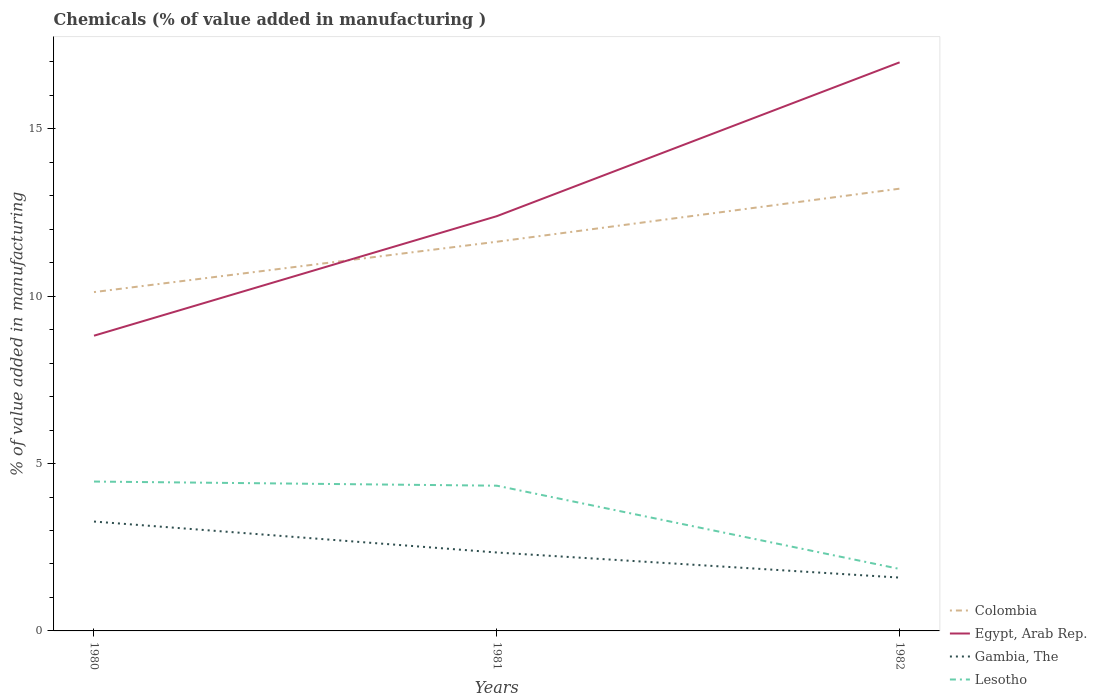How many different coloured lines are there?
Make the answer very short. 4. Does the line corresponding to Lesotho intersect with the line corresponding to Gambia, The?
Keep it short and to the point. No. Is the number of lines equal to the number of legend labels?
Ensure brevity in your answer.  Yes. Across all years, what is the maximum value added in manufacturing chemicals in Lesotho?
Keep it short and to the point. 1.85. What is the total value added in manufacturing chemicals in Lesotho in the graph?
Ensure brevity in your answer.  2.61. What is the difference between the highest and the second highest value added in manufacturing chemicals in Colombia?
Your response must be concise. 3.09. What is the difference between the highest and the lowest value added in manufacturing chemicals in Gambia, The?
Keep it short and to the point. 1. Does the graph contain grids?
Ensure brevity in your answer.  No. How are the legend labels stacked?
Provide a succinct answer. Vertical. What is the title of the graph?
Ensure brevity in your answer.  Chemicals (% of value added in manufacturing ). What is the label or title of the X-axis?
Provide a succinct answer. Years. What is the label or title of the Y-axis?
Provide a short and direct response. % of value added in manufacturing. What is the % of value added in manufacturing in Colombia in 1980?
Provide a succinct answer. 10.12. What is the % of value added in manufacturing in Egypt, Arab Rep. in 1980?
Your answer should be very brief. 8.82. What is the % of value added in manufacturing in Gambia, The in 1980?
Your answer should be compact. 3.27. What is the % of value added in manufacturing in Lesotho in 1980?
Keep it short and to the point. 4.46. What is the % of value added in manufacturing in Colombia in 1981?
Ensure brevity in your answer.  11.63. What is the % of value added in manufacturing in Egypt, Arab Rep. in 1981?
Your answer should be compact. 12.39. What is the % of value added in manufacturing in Gambia, The in 1981?
Keep it short and to the point. 2.34. What is the % of value added in manufacturing of Lesotho in 1981?
Offer a terse response. 4.34. What is the % of value added in manufacturing of Colombia in 1982?
Your answer should be compact. 13.21. What is the % of value added in manufacturing in Egypt, Arab Rep. in 1982?
Ensure brevity in your answer.  16.99. What is the % of value added in manufacturing of Gambia, The in 1982?
Your answer should be very brief. 1.59. What is the % of value added in manufacturing in Lesotho in 1982?
Give a very brief answer. 1.85. Across all years, what is the maximum % of value added in manufacturing in Colombia?
Offer a terse response. 13.21. Across all years, what is the maximum % of value added in manufacturing in Egypt, Arab Rep.?
Offer a very short reply. 16.99. Across all years, what is the maximum % of value added in manufacturing in Gambia, The?
Offer a very short reply. 3.27. Across all years, what is the maximum % of value added in manufacturing of Lesotho?
Keep it short and to the point. 4.46. Across all years, what is the minimum % of value added in manufacturing in Colombia?
Provide a short and direct response. 10.12. Across all years, what is the minimum % of value added in manufacturing of Egypt, Arab Rep.?
Provide a succinct answer. 8.82. Across all years, what is the minimum % of value added in manufacturing in Gambia, The?
Offer a very short reply. 1.59. Across all years, what is the minimum % of value added in manufacturing in Lesotho?
Keep it short and to the point. 1.85. What is the total % of value added in manufacturing of Colombia in the graph?
Your answer should be very brief. 34.96. What is the total % of value added in manufacturing in Egypt, Arab Rep. in the graph?
Offer a terse response. 38.2. What is the total % of value added in manufacturing in Gambia, The in the graph?
Make the answer very short. 7.2. What is the total % of value added in manufacturing in Lesotho in the graph?
Make the answer very short. 10.65. What is the difference between the % of value added in manufacturing of Colombia in 1980 and that in 1981?
Give a very brief answer. -1.51. What is the difference between the % of value added in manufacturing of Egypt, Arab Rep. in 1980 and that in 1981?
Keep it short and to the point. -3.57. What is the difference between the % of value added in manufacturing in Gambia, The in 1980 and that in 1981?
Keep it short and to the point. 0.92. What is the difference between the % of value added in manufacturing of Lesotho in 1980 and that in 1981?
Your answer should be very brief. 0.12. What is the difference between the % of value added in manufacturing in Colombia in 1980 and that in 1982?
Your answer should be very brief. -3.09. What is the difference between the % of value added in manufacturing in Egypt, Arab Rep. in 1980 and that in 1982?
Your answer should be very brief. -8.17. What is the difference between the % of value added in manufacturing of Gambia, The in 1980 and that in 1982?
Provide a short and direct response. 1.67. What is the difference between the % of value added in manufacturing of Lesotho in 1980 and that in 1982?
Ensure brevity in your answer.  2.61. What is the difference between the % of value added in manufacturing of Colombia in 1981 and that in 1982?
Your answer should be very brief. -1.59. What is the difference between the % of value added in manufacturing of Egypt, Arab Rep. in 1981 and that in 1982?
Make the answer very short. -4.6. What is the difference between the % of value added in manufacturing in Lesotho in 1981 and that in 1982?
Keep it short and to the point. 2.49. What is the difference between the % of value added in manufacturing of Colombia in 1980 and the % of value added in manufacturing of Egypt, Arab Rep. in 1981?
Provide a succinct answer. -2.27. What is the difference between the % of value added in manufacturing of Colombia in 1980 and the % of value added in manufacturing of Gambia, The in 1981?
Your response must be concise. 7.78. What is the difference between the % of value added in manufacturing in Colombia in 1980 and the % of value added in manufacturing in Lesotho in 1981?
Ensure brevity in your answer.  5.78. What is the difference between the % of value added in manufacturing in Egypt, Arab Rep. in 1980 and the % of value added in manufacturing in Gambia, The in 1981?
Provide a short and direct response. 6.48. What is the difference between the % of value added in manufacturing of Egypt, Arab Rep. in 1980 and the % of value added in manufacturing of Lesotho in 1981?
Your response must be concise. 4.48. What is the difference between the % of value added in manufacturing in Gambia, The in 1980 and the % of value added in manufacturing in Lesotho in 1981?
Your response must be concise. -1.07. What is the difference between the % of value added in manufacturing of Colombia in 1980 and the % of value added in manufacturing of Egypt, Arab Rep. in 1982?
Your answer should be very brief. -6.86. What is the difference between the % of value added in manufacturing in Colombia in 1980 and the % of value added in manufacturing in Gambia, The in 1982?
Your answer should be very brief. 8.53. What is the difference between the % of value added in manufacturing in Colombia in 1980 and the % of value added in manufacturing in Lesotho in 1982?
Offer a terse response. 8.27. What is the difference between the % of value added in manufacturing of Egypt, Arab Rep. in 1980 and the % of value added in manufacturing of Gambia, The in 1982?
Your response must be concise. 7.23. What is the difference between the % of value added in manufacturing in Egypt, Arab Rep. in 1980 and the % of value added in manufacturing in Lesotho in 1982?
Offer a very short reply. 6.97. What is the difference between the % of value added in manufacturing of Gambia, The in 1980 and the % of value added in manufacturing of Lesotho in 1982?
Give a very brief answer. 1.42. What is the difference between the % of value added in manufacturing in Colombia in 1981 and the % of value added in manufacturing in Egypt, Arab Rep. in 1982?
Give a very brief answer. -5.36. What is the difference between the % of value added in manufacturing in Colombia in 1981 and the % of value added in manufacturing in Gambia, The in 1982?
Your answer should be very brief. 10.03. What is the difference between the % of value added in manufacturing in Colombia in 1981 and the % of value added in manufacturing in Lesotho in 1982?
Give a very brief answer. 9.78. What is the difference between the % of value added in manufacturing of Egypt, Arab Rep. in 1981 and the % of value added in manufacturing of Gambia, The in 1982?
Your response must be concise. 10.8. What is the difference between the % of value added in manufacturing of Egypt, Arab Rep. in 1981 and the % of value added in manufacturing of Lesotho in 1982?
Keep it short and to the point. 10.54. What is the difference between the % of value added in manufacturing of Gambia, The in 1981 and the % of value added in manufacturing of Lesotho in 1982?
Your answer should be compact. 0.49. What is the average % of value added in manufacturing of Colombia per year?
Provide a short and direct response. 11.65. What is the average % of value added in manufacturing of Egypt, Arab Rep. per year?
Offer a terse response. 12.73. What is the average % of value added in manufacturing in Gambia, The per year?
Ensure brevity in your answer.  2.4. What is the average % of value added in manufacturing in Lesotho per year?
Provide a succinct answer. 3.55. In the year 1980, what is the difference between the % of value added in manufacturing of Colombia and % of value added in manufacturing of Egypt, Arab Rep.?
Offer a very short reply. 1.3. In the year 1980, what is the difference between the % of value added in manufacturing in Colombia and % of value added in manufacturing in Gambia, The?
Keep it short and to the point. 6.86. In the year 1980, what is the difference between the % of value added in manufacturing of Colombia and % of value added in manufacturing of Lesotho?
Offer a very short reply. 5.66. In the year 1980, what is the difference between the % of value added in manufacturing in Egypt, Arab Rep. and % of value added in manufacturing in Gambia, The?
Your response must be concise. 5.55. In the year 1980, what is the difference between the % of value added in manufacturing of Egypt, Arab Rep. and % of value added in manufacturing of Lesotho?
Give a very brief answer. 4.36. In the year 1980, what is the difference between the % of value added in manufacturing of Gambia, The and % of value added in manufacturing of Lesotho?
Your response must be concise. -1.19. In the year 1981, what is the difference between the % of value added in manufacturing of Colombia and % of value added in manufacturing of Egypt, Arab Rep.?
Your answer should be compact. -0.76. In the year 1981, what is the difference between the % of value added in manufacturing in Colombia and % of value added in manufacturing in Gambia, The?
Provide a short and direct response. 9.28. In the year 1981, what is the difference between the % of value added in manufacturing in Colombia and % of value added in manufacturing in Lesotho?
Offer a very short reply. 7.29. In the year 1981, what is the difference between the % of value added in manufacturing of Egypt, Arab Rep. and % of value added in manufacturing of Gambia, The?
Your response must be concise. 10.05. In the year 1981, what is the difference between the % of value added in manufacturing of Egypt, Arab Rep. and % of value added in manufacturing of Lesotho?
Ensure brevity in your answer.  8.05. In the year 1981, what is the difference between the % of value added in manufacturing of Gambia, The and % of value added in manufacturing of Lesotho?
Provide a succinct answer. -2. In the year 1982, what is the difference between the % of value added in manufacturing of Colombia and % of value added in manufacturing of Egypt, Arab Rep.?
Your response must be concise. -3.77. In the year 1982, what is the difference between the % of value added in manufacturing of Colombia and % of value added in manufacturing of Gambia, The?
Offer a terse response. 11.62. In the year 1982, what is the difference between the % of value added in manufacturing of Colombia and % of value added in manufacturing of Lesotho?
Your answer should be compact. 11.36. In the year 1982, what is the difference between the % of value added in manufacturing in Egypt, Arab Rep. and % of value added in manufacturing in Gambia, The?
Your answer should be very brief. 15.39. In the year 1982, what is the difference between the % of value added in manufacturing in Egypt, Arab Rep. and % of value added in manufacturing in Lesotho?
Your answer should be very brief. 15.14. In the year 1982, what is the difference between the % of value added in manufacturing of Gambia, The and % of value added in manufacturing of Lesotho?
Offer a very short reply. -0.26. What is the ratio of the % of value added in manufacturing of Colombia in 1980 to that in 1981?
Offer a terse response. 0.87. What is the ratio of the % of value added in manufacturing of Egypt, Arab Rep. in 1980 to that in 1981?
Ensure brevity in your answer.  0.71. What is the ratio of the % of value added in manufacturing in Gambia, The in 1980 to that in 1981?
Offer a terse response. 1.39. What is the ratio of the % of value added in manufacturing in Lesotho in 1980 to that in 1981?
Offer a terse response. 1.03. What is the ratio of the % of value added in manufacturing of Colombia in 1980 to that in 1982?
Provide a short and direct response. 0.77. What is the ratio of the % of value added in manufacturing of Egypt, Arab Rep. in 1980 to that in 1982?
Keep it short and to the point. 0.52. What is the ratio of the % of value added in manufacturing of Gambia, The in 1980 to that in 1982?
Your answer should be very brief. 2.05. What is the ratio of the % of value added in manufacturing in Lesotho in 1980 to that in 1982?
Give a very brief answer. 2.41. What is the ratio of the % of value added in manufacturing in Colombia in 1981 to that in 1982?
Provide a short and direct response. 0.88. What is the ratio of the % of value added in manufacturing in Egypt, Arab Rep. in 1981 to that in 1982?
Provide a succinct answer. 0.73. What is the ratio of the % of value added in manufacturing of Gambia, The in 1981 to that in 1982?
Provide a short and direct response. 1.47. What is the ratio of the % of value added in manufacturing in Lesotho in 1981 to that in 1982?
Keep it short and to the point. 2.34. What is the difference between the highest and the second highest % of value added in manufacturing of Colombia?
Make the answer very short. 1.59. What is the difference between the highest and the second highest % of value added in manufacturing of Egypt, Arab Rep.?
Your answer should be compact. 4.6. What is the difference between the highest and the second highest % of value added in manufacturing in Gambia, The?
Make the answer very short. 0.92. What is the difference between the highest and the second highest % of value added in manufacturing in Lesotho?
Keep it short and to the point. 0.12. What is the difference between the highest and the lowest % of value added in manufacturing in Colombia?
Offer a very short reply. 3.09. What is the difference between the highest and the lowest % of value added in manufacturing in Egypt, Arab Rep.?
Provide a short and direct response. 8.17. What is the difference between the highest and the lowest % of value added in manufacturing in Gambia, The?
Provide a succinct answer. 1.67. What is the difference between the highest and the lowest % of value added in manufacturing in Lesotho?
Offer a terse response. 2.61. 